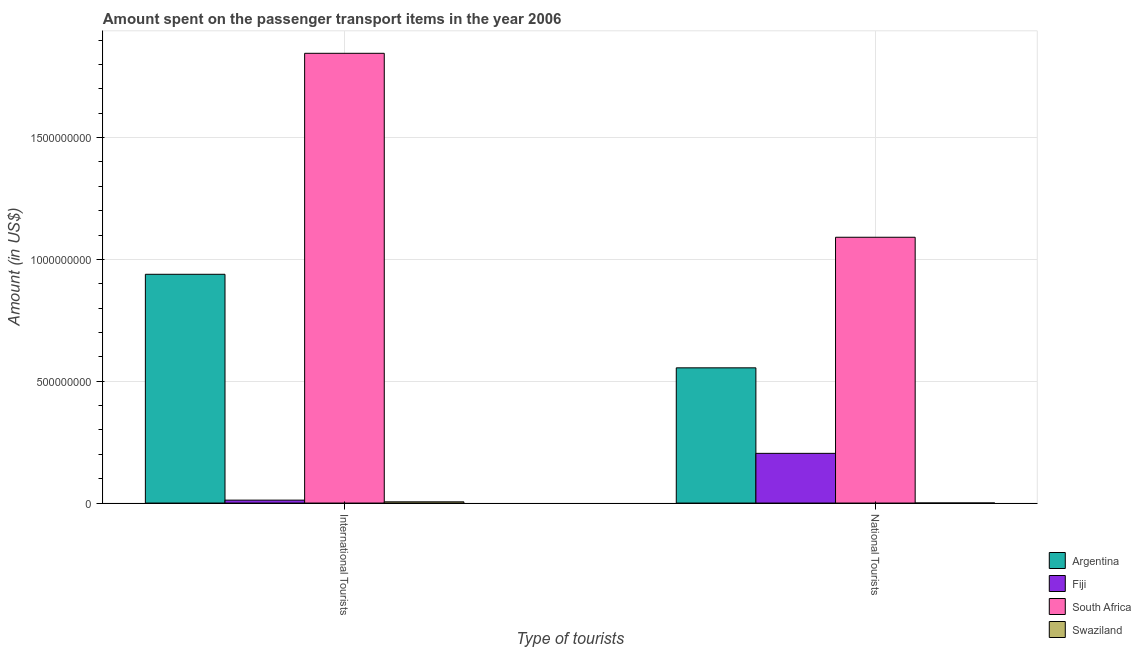How many different coloured bars are there?
Offer a terse response. 4. Are the number of bars on each tick of the X-axis equal?
Offer a very short reply. Yes. What is the label of the 2nd group of bars from the left?
Keep it short and to the point. National Tourists. What is the amount spent on transport items of international tourists in South Africa?
Provide a short and direct response. 1.85e+09. Across all countries, what is the maximum amount spent on transport items of international tourists?
Your answer should be compact. 1.85e+09. Across all countries, what is the minimum amount spent on transport items of national tourists?
Offer a terse response. 1.00e+05. In which country was the amount spent on transport items of national tourists maximum?
Your answer should be very brief. South Africa. In which country was the amount spent on transport items of national tourists minimum?
Your answer should be compact. Swaziland. What is the total amount spent on transport items of international tourists in the graph?
Keep it short and to the point. 2.80e+09. What is the difference between the amount spent on transport items of national tourists in Argentina and that in South Africa?
Your response must be concise. -5.36e+08. What is the difference between the amount spent on transport items of national tourists in South Africa and the amount spent on transport items of international tourists in Swaziland?
Provide a short and direct response. 1.09e+09. What is the average amount spent on transport items of international tourists per country?
Offer a very short reply. 7.00e+08. What is the difference between the amount spent on transport items of national tourists and amount spent on transport items of international tourists in Fiji?
Your response must be concise. 1.92e+08. In how many countries, is the amount spent on transport items of international tourists greater than 900000000 US$?
Provide a short and direct response. 2. What does the 2nd bar from the right in International Tourists represents?
Give a very brief answer. South Africa. How many bars are there?
Your response must be concise. 8. How many countries are there in the graph?
Make the answer very short. 4. What is the difference between two consecutive major ticks on the Y-axis?
Offer a very short reply. 5.00e+08. Are the values on the major ticks of Y-axis written in scientific E-notation?
Offer a terse response. No. Does the graph contain any zero values?
Your answer should be compact. No. Does the graph contain grids?
Give a very brief answer. Yes. Where does the legend appear in the graph?
Give a very brief answer. Bottom right. How many legend labels are there?
Give a very brief answer. 4. How are the legend labels stacked?
Keep it short and to the point. Vertical. What is the title of the graph?
Give a very brief answer. Amount spent on the passenger transport items in the year 2006. Does "Armenia" appear as one of the legend labels in the graph?
Your response must be concise. No. What is the label or title of the X-axis?
Your answer should be compact. Type of tourists. What is the label or title of the Y-axis?
Your answer should be compact. Amount (in US$). What is the Amount (in US$) of Argentina in International Tourists?
Your response must be concise. 9.39e+08. What is the Amount (in US$) of Fiji in International Tourists?
Your response must be concise. 1.20e+07. What is the Amount (in US$) of South Africa in International Tourists?
Your answer should be very brief. 1.85e+09. What is the Amount (in US$) in Argentina in National Tourists?
Give a very brief answer. 5.55e+08. What is the Amount (in US$) in Fiji in National Tourists?
Give a very brief answer. 2.04e+08. What is the Amount (in US$) of South Africa in National Tourists?
Provide a short and direct response. 1.09e+09. Across all Type of tourists, what is the maximum Amount (in US$) in Argentina?
Your response must be concise. 9.39e+08. Across all Type of tourists, what is the maximum Amount (in US$) of Fiji?
Ensure brevity in your answer.  2.04e+08. Across all Type of tourists, what is the maximum Amount (in US$) of South Africa?
Ensure brevity in your answer.  1.85e+09. Across all Type of tourists, what is the minimum Amount (in US$) in Argentina?
Ensure brevity in your answer.  5.55e+08. Across all Type of tourists, what is the minimum Amount (in US$) in South Africa?
Offer a very short reply. 1.09e+09. Across all Type of tourists, what is the minimum Amount (in US$) in Swaziland?
Your answer should be compact. 1.00e+05. What is the total Amount (in US$) of Argentina in the graph?
Make the answer very short. 1.49e+09. What is the total Amount (in US$) in Fiji in the graph?
Make the answer very short. 2.16e+08. What is the total Amount (in US$) of South Africa in the graph?
Ensure brevity in your answer.  2.94e+09. What is the total Amount (in US$) in Swaziland in the graph?
Provide a short and direct response. 5.10e+06. What is the difference between the Amount (in US$) of Argentina in International Tourists and that in National Tourists?
Provide a short and direct response. 3.84e+08. What is the difference between the Amount (in US$) in Fiji in International Tourists and that in National Tourists?
Your response must be concise. -1.92e+08. What is the difference between the Amount (in US$) in South Africa in International Tourists and that in National Tourists?
Ensure brevity in your answer.  7.55e+08. What is the difference between the Amount (in US$) in Swaziland in International Tourists and that in National Tourists?
Provide a short and direct response. 4.90e+06. What is the difference between the Amount (in US$) in Argentina in International Tourists and the Amount (in US$) in Fiji in National Tourists?
Ensure brevity in your answer.  7.35e+08. What is the difference between the Amount (in US$) in Argentina in International Tourists and the Amount (in US$) in South Africa in National Tourists?
Give a very brief answer. -1.52e+08. What is the difference between the Amount (in US$) of Argentina in International Tourists and the Amount (in US$) of Swaziland in National Tourists?
Provide a short and direct response. 9.39e+08. What is the difference between the Amount (in US$) of Fiji in International Tourists and the Amount (in US$) of South Africa in National Tourists?
Your answer should be compact. -1.08e+09. What is the difference between the Amount (in US$) of Fiji in International Tourists and the Amount (in US$) of Swaziland in National Tourists?
Make the answer very short. 1.19e+07. What is the difference between the Amount (in US$) of South Africa in International Tourists and the Amount (in US$) of Swaziland in National Tourists?
Ensure brevity in your answer.  1.85e+09. What is the average Amount (in US$) in Argentina per Type of tourists?
Your answer should be compact. 7.47e+08. What is the average Amount (in US$) of Fiji per Type of tourists?
Keep it short and to the point. 1.08e+08. What is the average Amount (in US$) in South Africa per Type of tourists?
Provide a short and direct response. 1.47e+09. What is the average Amount (in US$) of Swaziland per Type of tourists?
Ensure brevity in your answer.  2.55e+06. What is the difference between the Amount (in US$) in Argentina and Amount (in US$) in Fiji in International Tourists?
Provide a short and direct response. 9.27e+08. What is the difference between the Amount (in US$) of Argentina and Amount (in US$) of South Africa in International Tourists?
Your response must be concise. -9.07e+08. What is the difference between the Amount (in US$) in Argentina and Amount (in US$) in Swaziland in International Tourists?
Offer a terse response. 9.34e+08. What is the difference between the Amount (in US$) of Fiji and Amount (in US$) of South Africa in International Tourists?
Provide a succinct answer. -1.83e+09. What is the difference between the Amount (in US$) in South Africa and Amount (in US$) in Swaziland in International Tourists?
Offer a terse response. 1.84e+09. What is the difference between the Amount (in US$) of Argentina and Amount (in US$) of Fiji in National Tourists?
Ensure brevity in your answer.  3.51e+08. What is the difference between the Amount (in US$) in Argentina and Amount (in US$) in South Africa in National Tourists?
Keep it short and to the point. -5.36e+08. What is the difference between the Amount (in US$) in Argentina and Amount (in US$) in Swaziland in National Tourists?
Your response must be concise. 5.55e+08. What is the difference between the Amount (in US$) in Fiji and Amount (in US$) in South Africa in National Tourists?
Give a very brief answer. -8.87e+08. What is the difference between the Amount (in US$) of Fiji and Amount (in US$) of Swaziland in National Tourists?
Offer a very short reply. 2.04e+08. What is the difference between the Amount (in US$) of South Africa and Amount (in US$) of Swaziland in National Tourists?
Provide a succinct answer. 1.09e+09. What is the ratio of the Amount (in US$) of Argentina in International Tourists to that in National Tourists?
Offer a terse response. 1.69. What is the ratio of the Amount (in US$) in Fiji in International Tourists to that in National Tourists?
Your answer should be very brief. 0.06. What is the ratio of the Amount (in US$) in South Africa in International Tourists to that in National Tourists?
Keep it short and to the point. 1.69. What is the difference between the highest and the second highest Amount (in US$) of Argentina?
Provide a succinct answer. 3.84e+08. What is the difference between the highest and the second highest Amount (in US$) in Fiji?
Your response must be concise. 1.92e+08. What is the difference between the highest and the second highest Amount (in US$) of South Africa?
Your answer should be very brief. 7.55e+08. What is the difference between the highest and the second highest Amount (in US$) of Swaziland?
Your response must be concise. 4.90e+06. What is the difference between the highest and the lowest Amount (in US$) in Argentina?
Make the answer very short. 3.84e+08. What is the difference between the highest and the lowest Amount (in US$) in Fiji?
Ensure brevity in your answer.  1.92e+08. What is the difference between the highest and the lowest Amount (in US$) of South Africa?
Provide a short and direct response. 7.55e+08. What is the difference between the highest and the lowest Amount (in US$) in Swaziland?
Make the answer very short. 4.90e+06. 